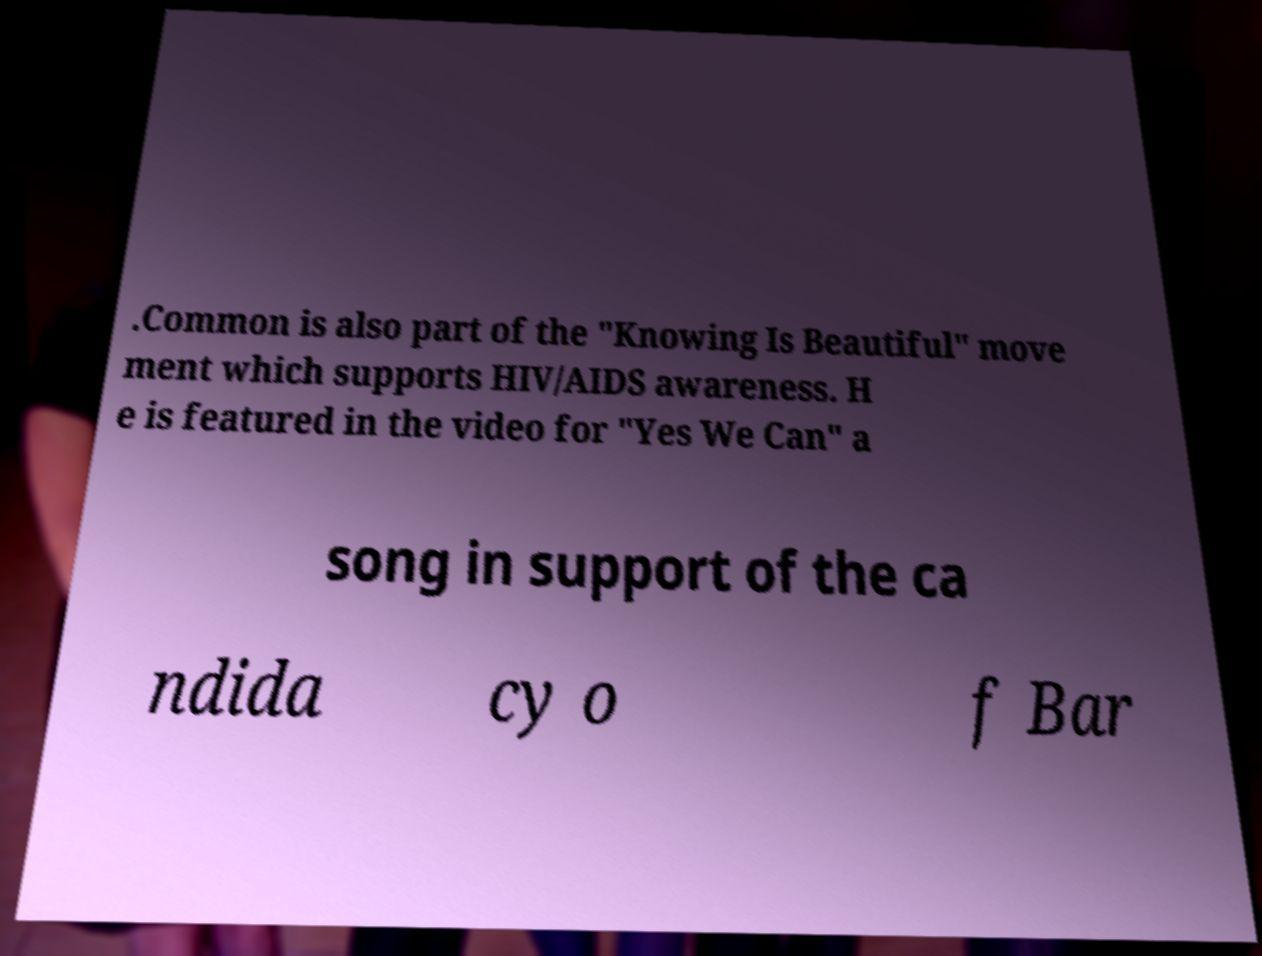For documentation purposes, I need the text within this image transcribed. Could you provide that? .Common is also part of the "Knowing Is Beautiful" move ment which supports HIV/AIDS awareness. H e is featured in the video for "Yes We Can" a song in support of the ca ndida cy o f Bar 